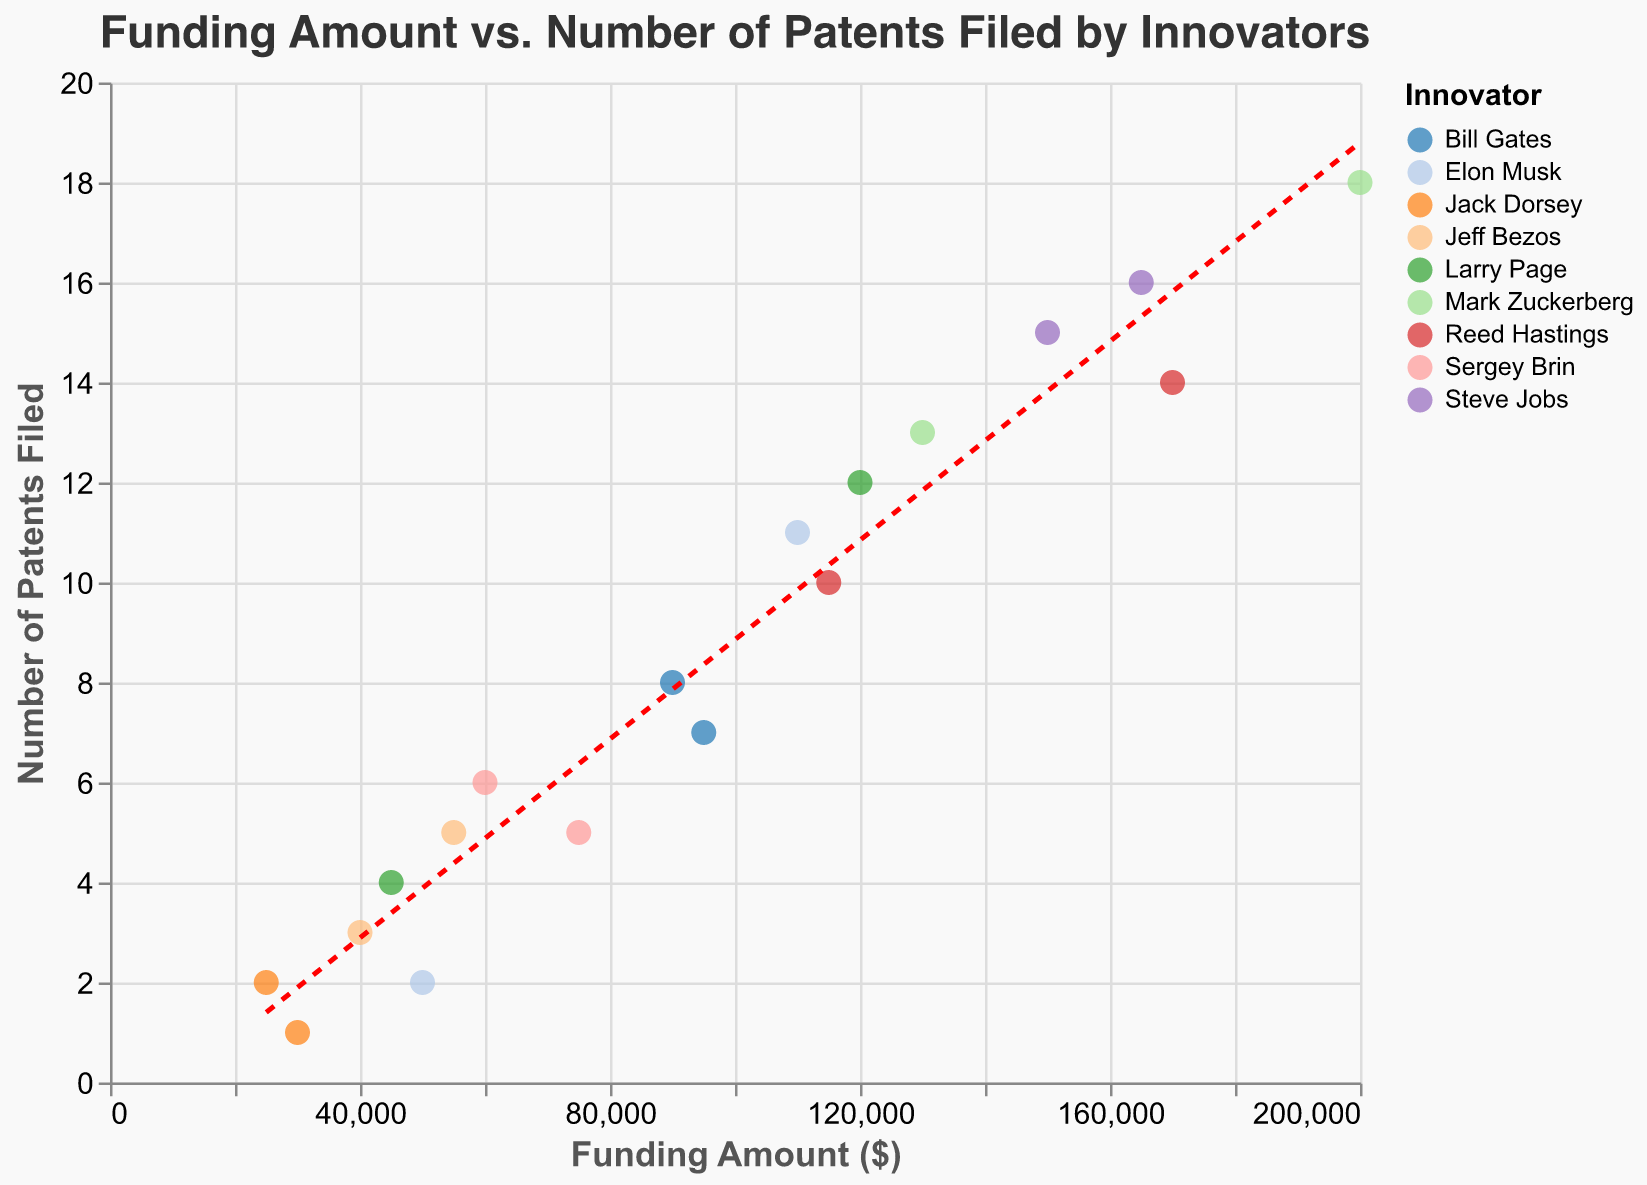What's the title of the figure? The title of the figure is clearly displayed at the top of the plot. It reads "Funding Amount vs. Number of Patents Filed by Innovators".
Answer: Funding Amount vs. Number of Patents Filed by Innovators How many data points are displayed in the figure? To count the data points, look at each point on the scatter plot. There are 18 points on the plot.
Answer: 18 Which innovator received the highest funding amount? By observing the positions of the points on the x-axis (Funding Amount), the innovator with the highest funding amount is the one farthest to the right. Mark Zuckerberg received the highest funding, which is $200,000.
Answer: Mark Zuckerberg What's the range of the number of patents filed by all innovators? Identify the minimum and maximum y-values on the y-axis (Number of Patents). The least number of patents filed is 1, and the most is 18. The range is 1 to 18.
Answer: 1 to 18 How many innovators have filed exactly 5 patents? Look at the y-axis for the y-value of 5 and count the points aligned with this value. Three innovators (Sergey Brin, Jeff Bezos, and Jack Dorsey) have filed exactly 5 patents.
Answer: 3 What is the trend in the scatter plot? The trend is indicated by the red dashed line. It shows a positive correlation; as the funding amount increases, the number of patents filed also tends to increase.
Answer: Positive correlation Which innovator appears twice in the data set and what are their funding amounts? By checking the tooltip or the color-coded legend, Elon Musk appears twice with funding amounts of $50,000 and $110,000.
Answer: Elon Musk, $50,000 and $110,000 Who has filed the least number of patents and what is their funding amount? Look for the lowest y-value point (number of patents) and check the corresponding x-value and innovator. Jack Dorsey has filed the least number of patents (1) with a funding amount of $30,000.
Answer: Jack Dorsey, $30,000 What is the average funding amount received by Steve Jobs? Steve Jobs appears twice in the dataset with funding amounts $150,000 and $165,000. To find the average, sum them up and divide by 2, (150,000 + 165,000)/2 = $157,500.
Answer: $157,500 